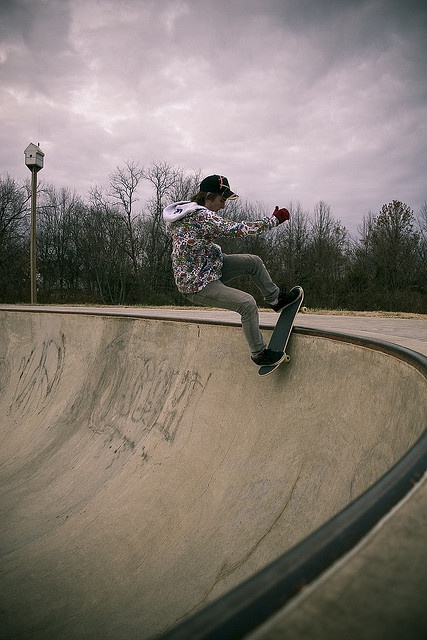Describe the objects in this image and their specific colors. I can see people in purple, black, gray, and darkgray tones and skateboard in gray, black, darkgray, and olive tones in this image. 